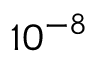<formula> <loc_0><loc_0><loc_500><loc_500>1 0 ^ { - 8 }</formula> 